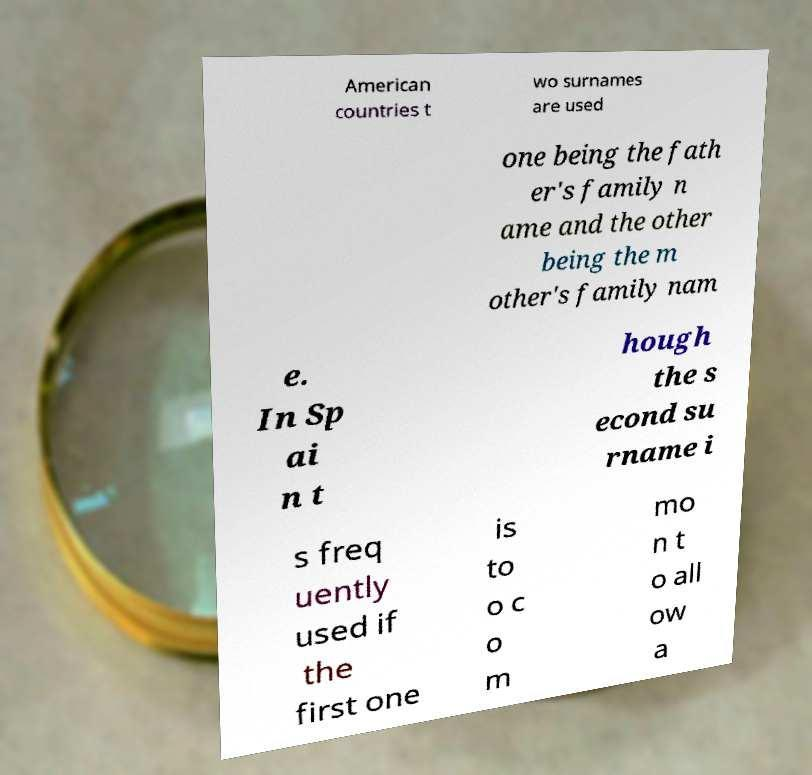Please read and relay the text visible in this image. What does it say? American countries t wo surnames are used one being the fath er's family n ame and the other being the m other's family nam e. In Sp ai n t hough the s econd su rname i s freq uently used if the first one is to o c o m mo n t o all ow a 